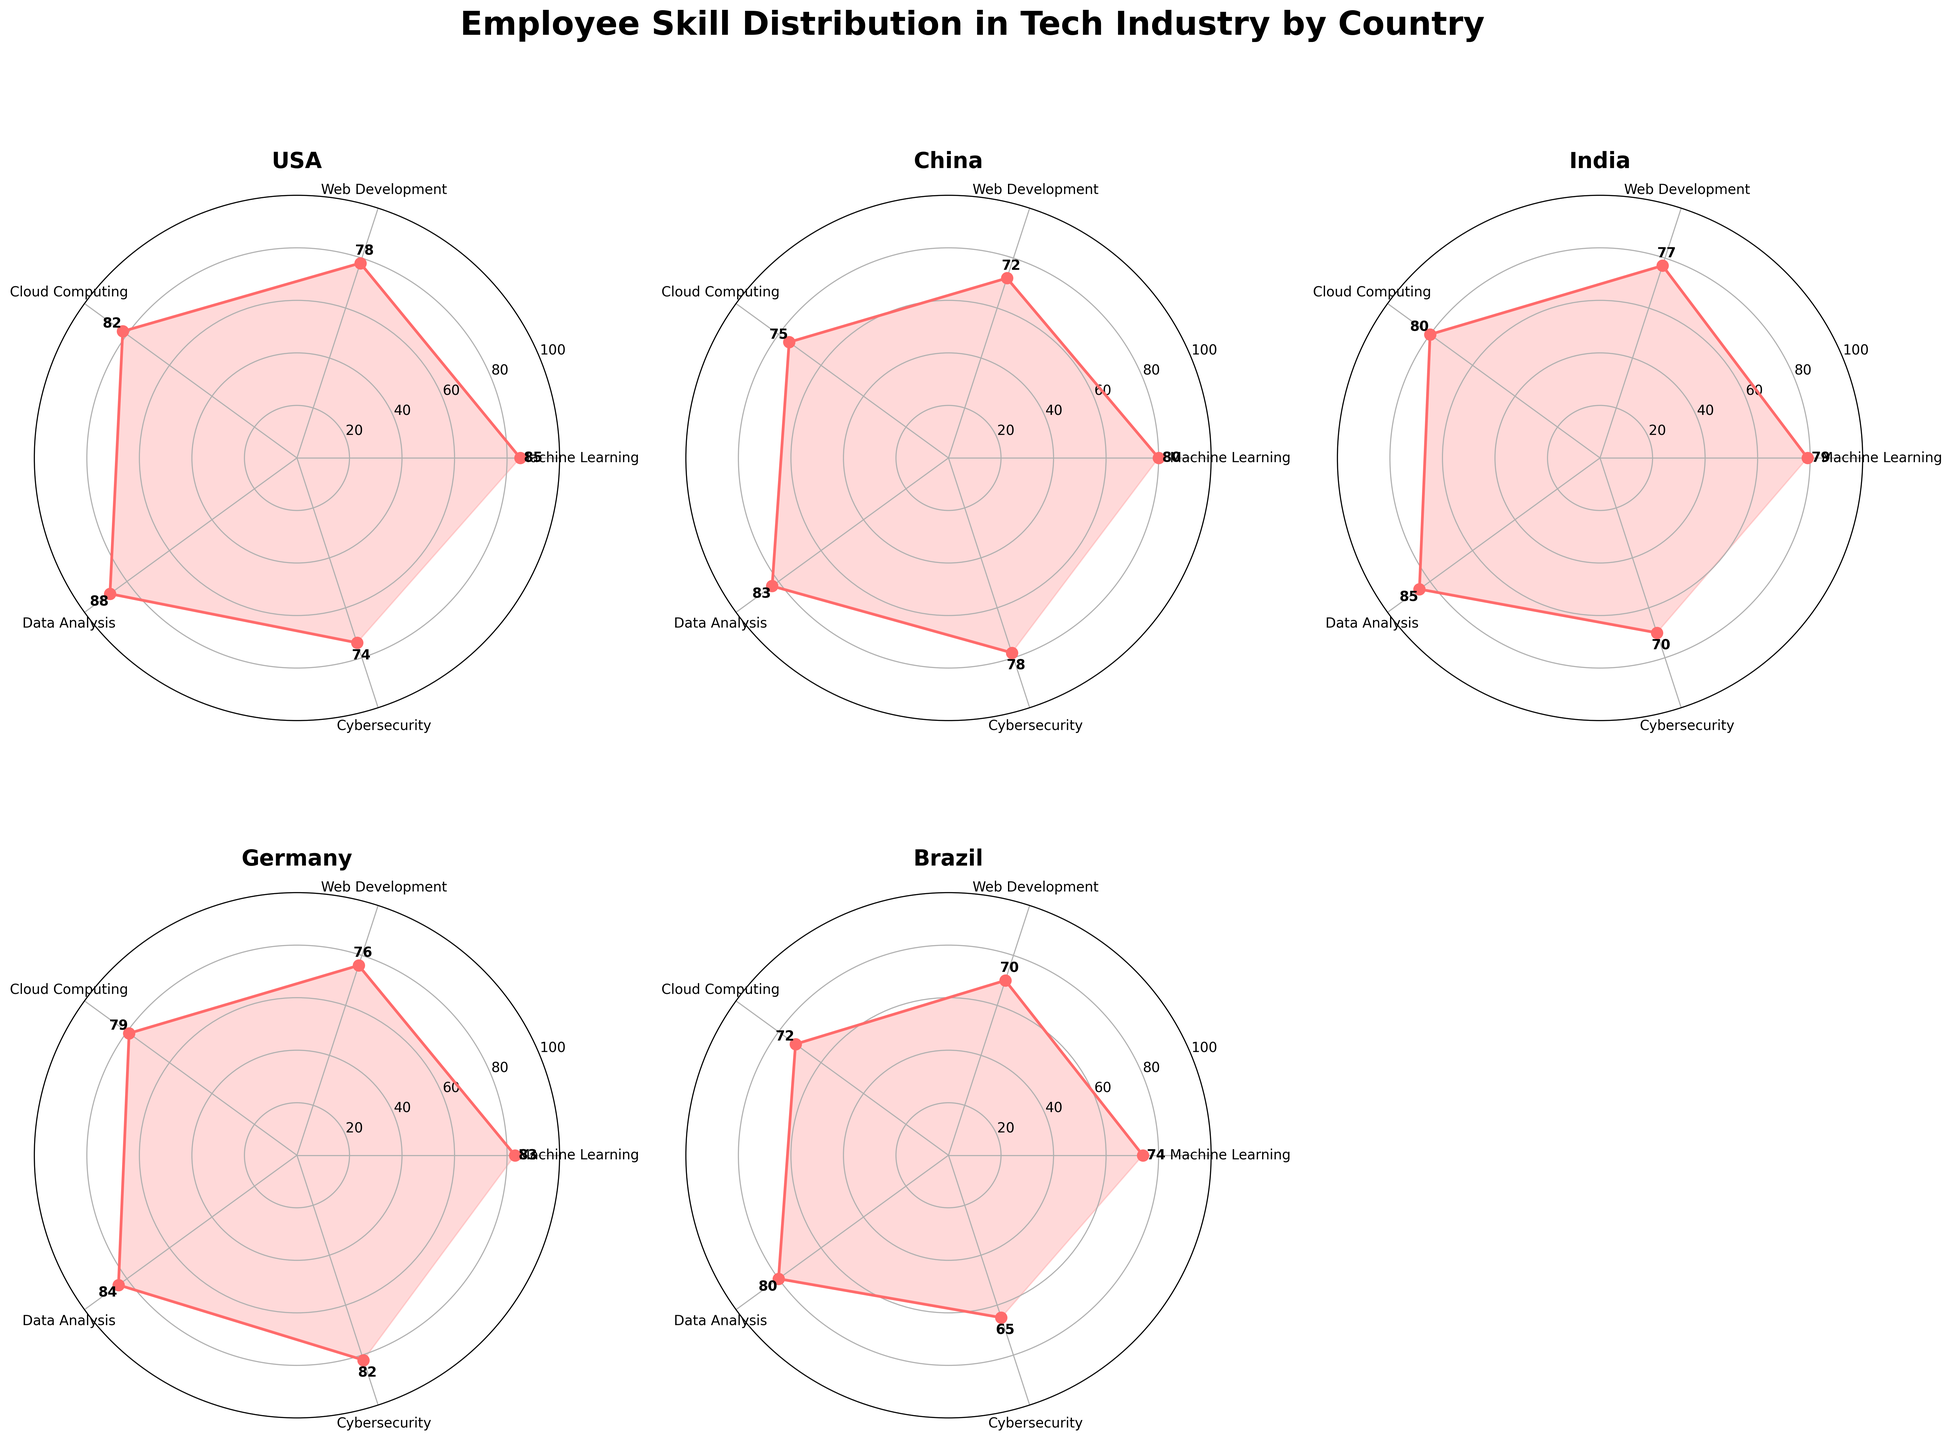What is the proficiency of Cybersecurity skills in the USA? To find the proficiency of Cybersecurity skills in the USA, look for the value listed next to the "Cybersecurity" label within the USA's polar chart.
Answer: 74 Which country has the highest proficiency in Data Analysis skills? Compare the Data Analysis proficiency values across all countries. USA has 88, China has 83, India has 85, Germany has 84, and Brazil has 80. The highest value is 88, which is for the USA.
Answer: USA What is the average proficiency in Web Development skills across all countries? Add the Web Development proficiency values for all countries and divide by the number of countries. Specifically: (78 + 72 + 77 + 76 + 70) / 5 = 373 / 5 = 74.6
Answer: 74.6 Which country has the lowest overall proficiency in Machine Learning skills? Compare the Machine Learning proficiency values across all countries. USA has 85, China has 80, India has 79, Germany has 83, and Brazil has 74. The lowest value is 74, which is for Brazil.
Answer: Brazil How many skills are evaluated in each country? The number of skills can be counted from any polar chart, as all countries are evaluated on the same set of skills. USA's chart shows 5 skills: Machine Learning, Web Development, Cloud Computing, Data Analysis, and Cybersecurity.
Answer: 5 Which skill in Germany has the highest proficiency rating? Look at Germany's polar chart and compare the proficiency values for each skill. The highest proficiency is for "Cybersecurity" with a value of 82.
Answer: Cybersecurity What is the difference in proficiency for Cloud Computing skills between Germany and Brazil? Subtract Brazil's Cloud Computing proficiency from Germany's Cloud Computing proficiency: 79 - 72 = 7.
Answer: 7 How do the Cybersecurity skills in China compare to those in India? Compare the proficiency values of Cybersecurity skills between China and India. China has a proficiency of 78, while India has a proficiency of 70. China has a higher proficiency by 8.
Answer: China by 8 What is the total number of data points labeled on the plot? Each polar chart has 5 points, one for each skill, and there are 5 countries shown (since one subplot is blank). Therefore, the total number of points is 5 * 5 = 25.
Answer: 25 